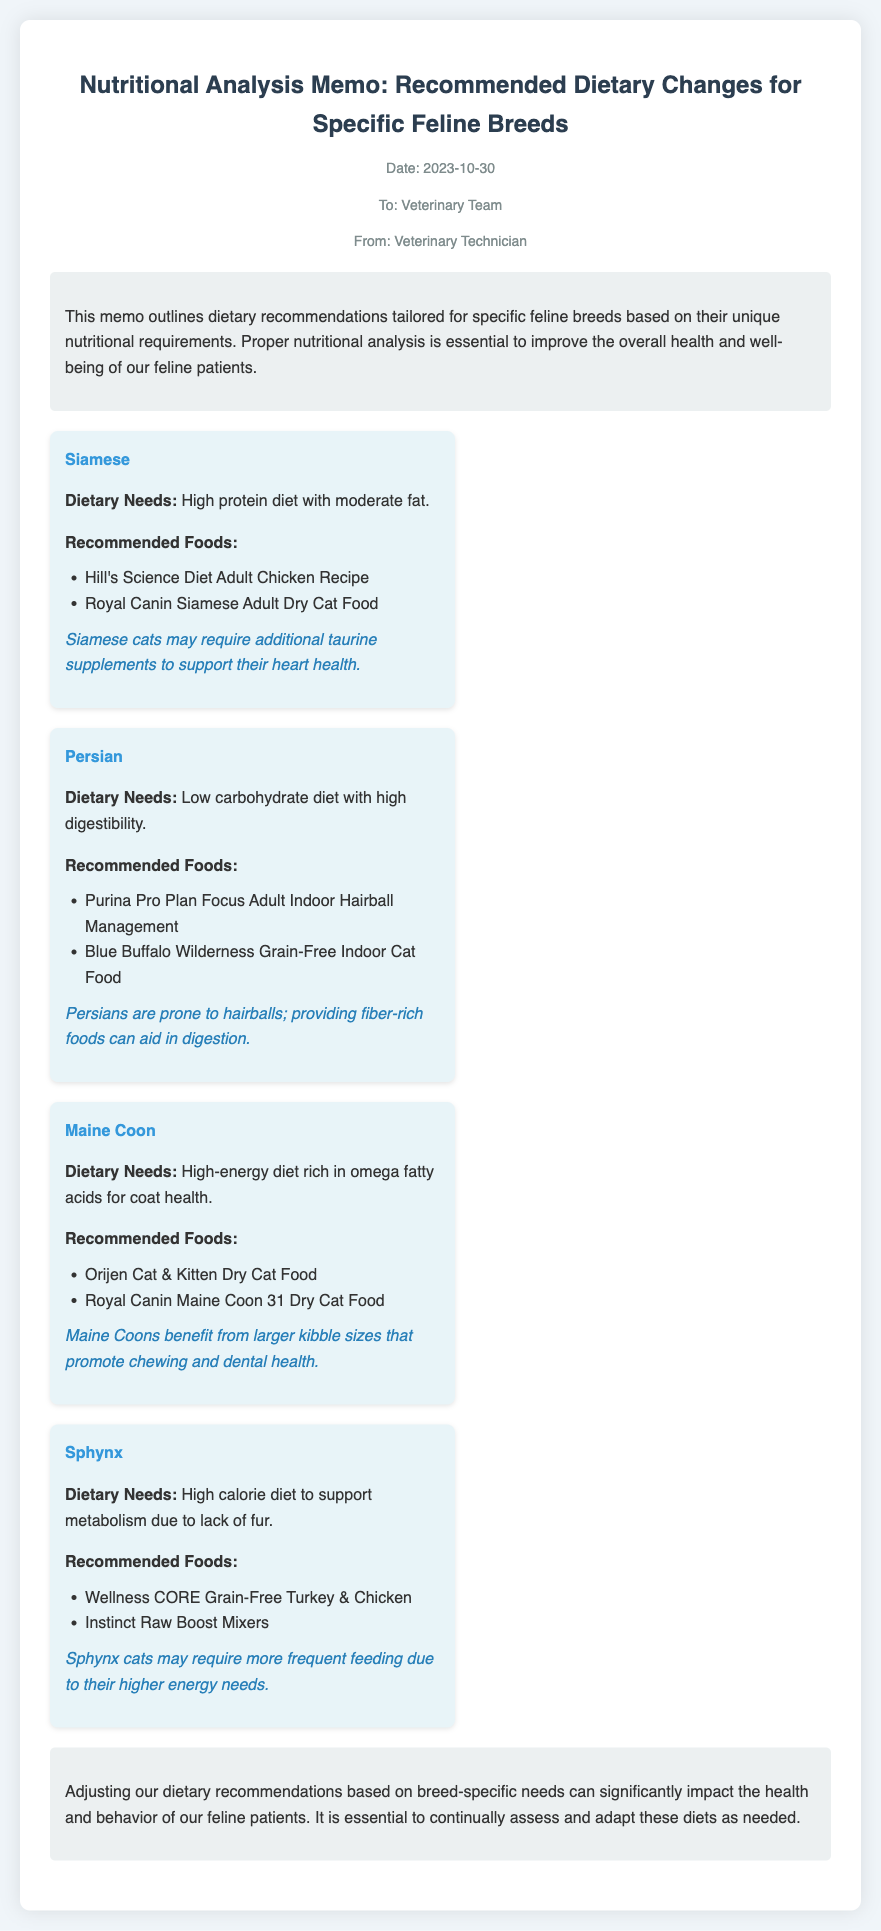What is the date of the memo? The date of the memo is stated at the top, indicating when it was created.
Answer: 2023-10-30 Who is the memo addressed to? The memo specifies the intended audience in the header.
Answer: Veterinary Team What breed has a high protein diet with moderate fat? This breed's dietary needs are detailed in the recommendations section of the memo.
Answer: Siamese Which food is recommended for Persian cats? This food falls under the recommended foods for the Persian breed in the document.
Answer: Purina Pro Plan Focus Adult Indoor Hairball Management What specific nutrition do Maine Coons benefit from? The insights for Maine Coons highlight their nutritional benefits found in the dietary recommendations.
Answer: Omega fatty acids How often should Sphynx cats be fed? The information on feeding frequency is addressed in the insights for Sphynx cats.
Answer: More frequent feeding What type of document is this? The overall intent and format indicate the category of the document.
Answer: Memo 